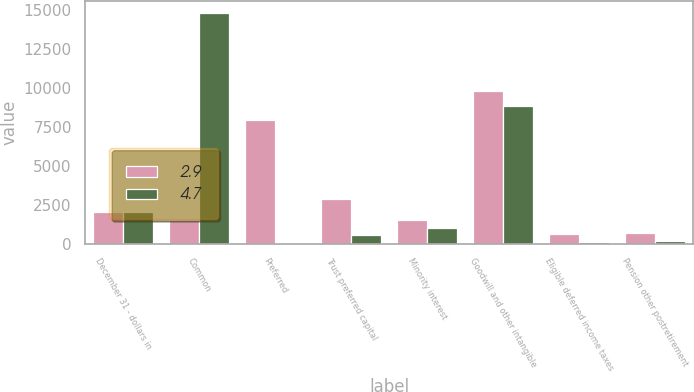Convert chart to OTSL. <chart><loc_0><loc_0><loc_500><loc_500><stacked_bar_chart><ecel><fcel>December 31 - dollars in<fcel>Common<fcel>Preferred<fcel>Trust preferred capital<fcel>Minority interest<fcel>Goodwill and other intangible<fcel>Eligible deferred income taxes<fcel>Pension other postretirement<nl><fcel>2.9<fcel>2008<fcel>1506<fcel>7932<fcel>2898<fcel>1506<fcel>9800<fcel>594<fcel>666<nl><fcel>4.7<fcel>2007<fcel>14847<fcel>7<fcel>572<fcel>985<fcel>8853<fcel>119<fcel>177<nl></chart> 